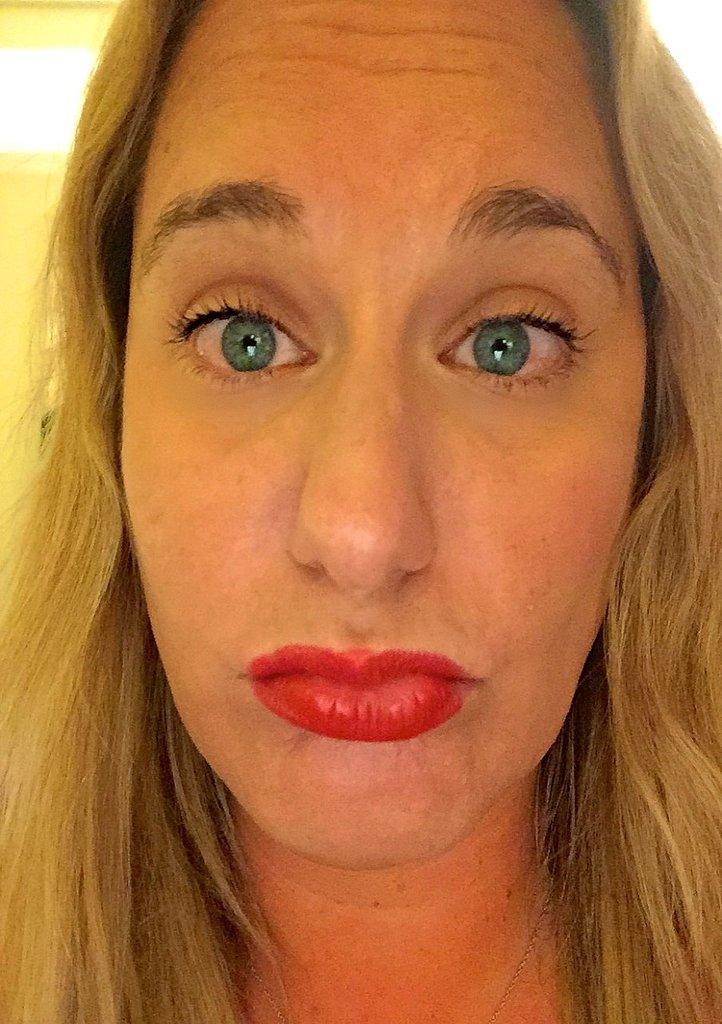Who is present in the image? There is a woman in the image. What can be seen in the background of the image? There is a wall in the background of the image. How many leaves are on the sink in the image? There is no sink or leaves present in the image. 